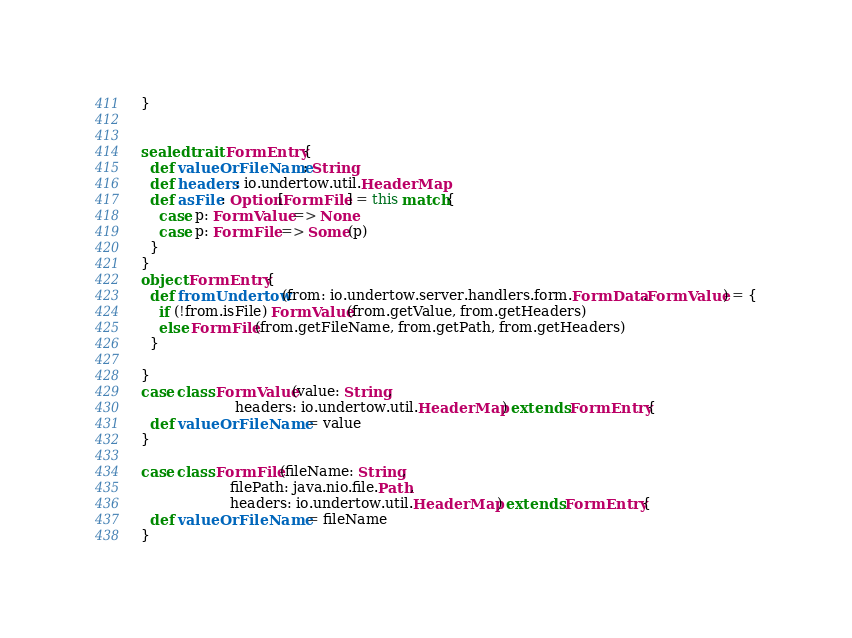Convert code to text. <code><loc_0><loc_0><loc_500><loc_500><_Scala_>}


sealed trait FormEntry{
  def valueOrFileName: String
  def headers: io.undertow.util.HeaderMap
  def asFile: Option[FormFile] = this match{
    case p: FormValue => None
    case p: FormFile => Some(p)
  }
}
object FormEntry{
  def fromUndertow(from: io.undertow.server.handlers.form.FormData.FormValue) = {
    if (!from.isFile) FormValue(from.getValue, from.getHeaders)
    else FormFile(from.getFileName, from.getPath, from.getHeaders)
  }

}
case class FormValue(value: String,
                     headers: io.undertow.util.HeaderMap) extends FormEntry{
  def valueOrFileName = value
}

case class FormFile(fileName: String,
                    filePath: java.nio.file.Path,
                    headers: io.undertow.util.HeaderMap) extends FormEntry{
  def valueOrFileName = fileName
}
</code> 